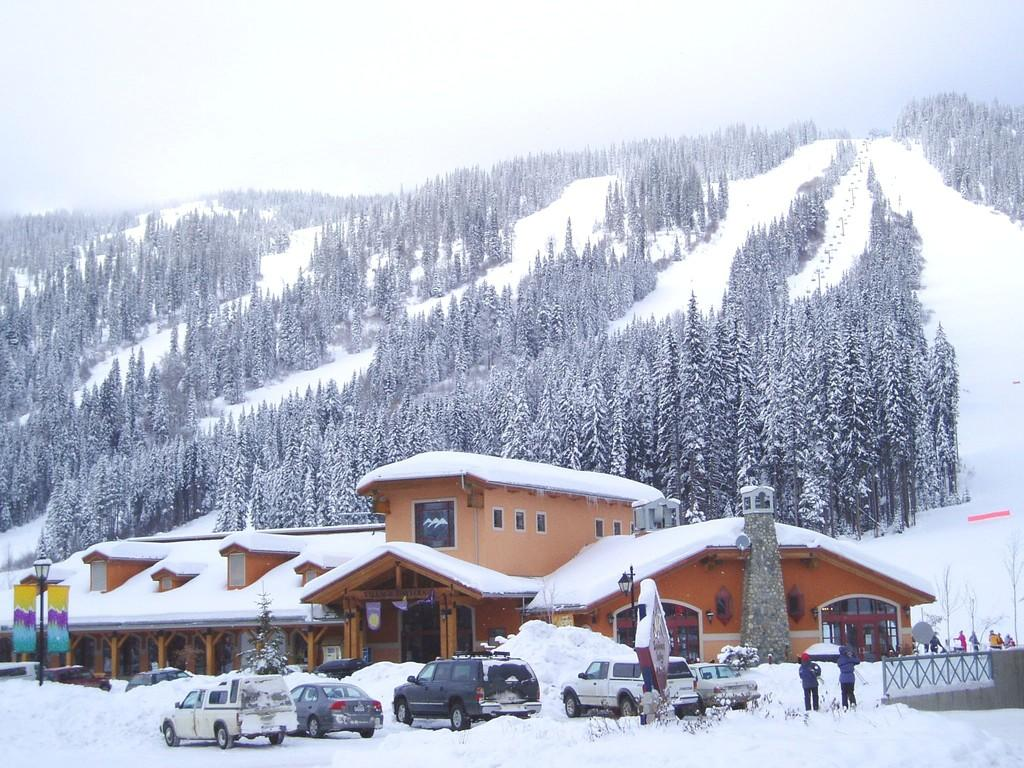What is happening on the snow in the image? There are vehicles on the snow in the image. What can be seen in the distance behind the vehicles? There is a building in the background of the image. What else is visible in the background of the image? Trees covered with snow are present in the background of the image. What is the angle of the desire in the image? There is no reference to an angle or desire in the image; it features vehicles on the snow with a building and snow-covered trees in the background. 